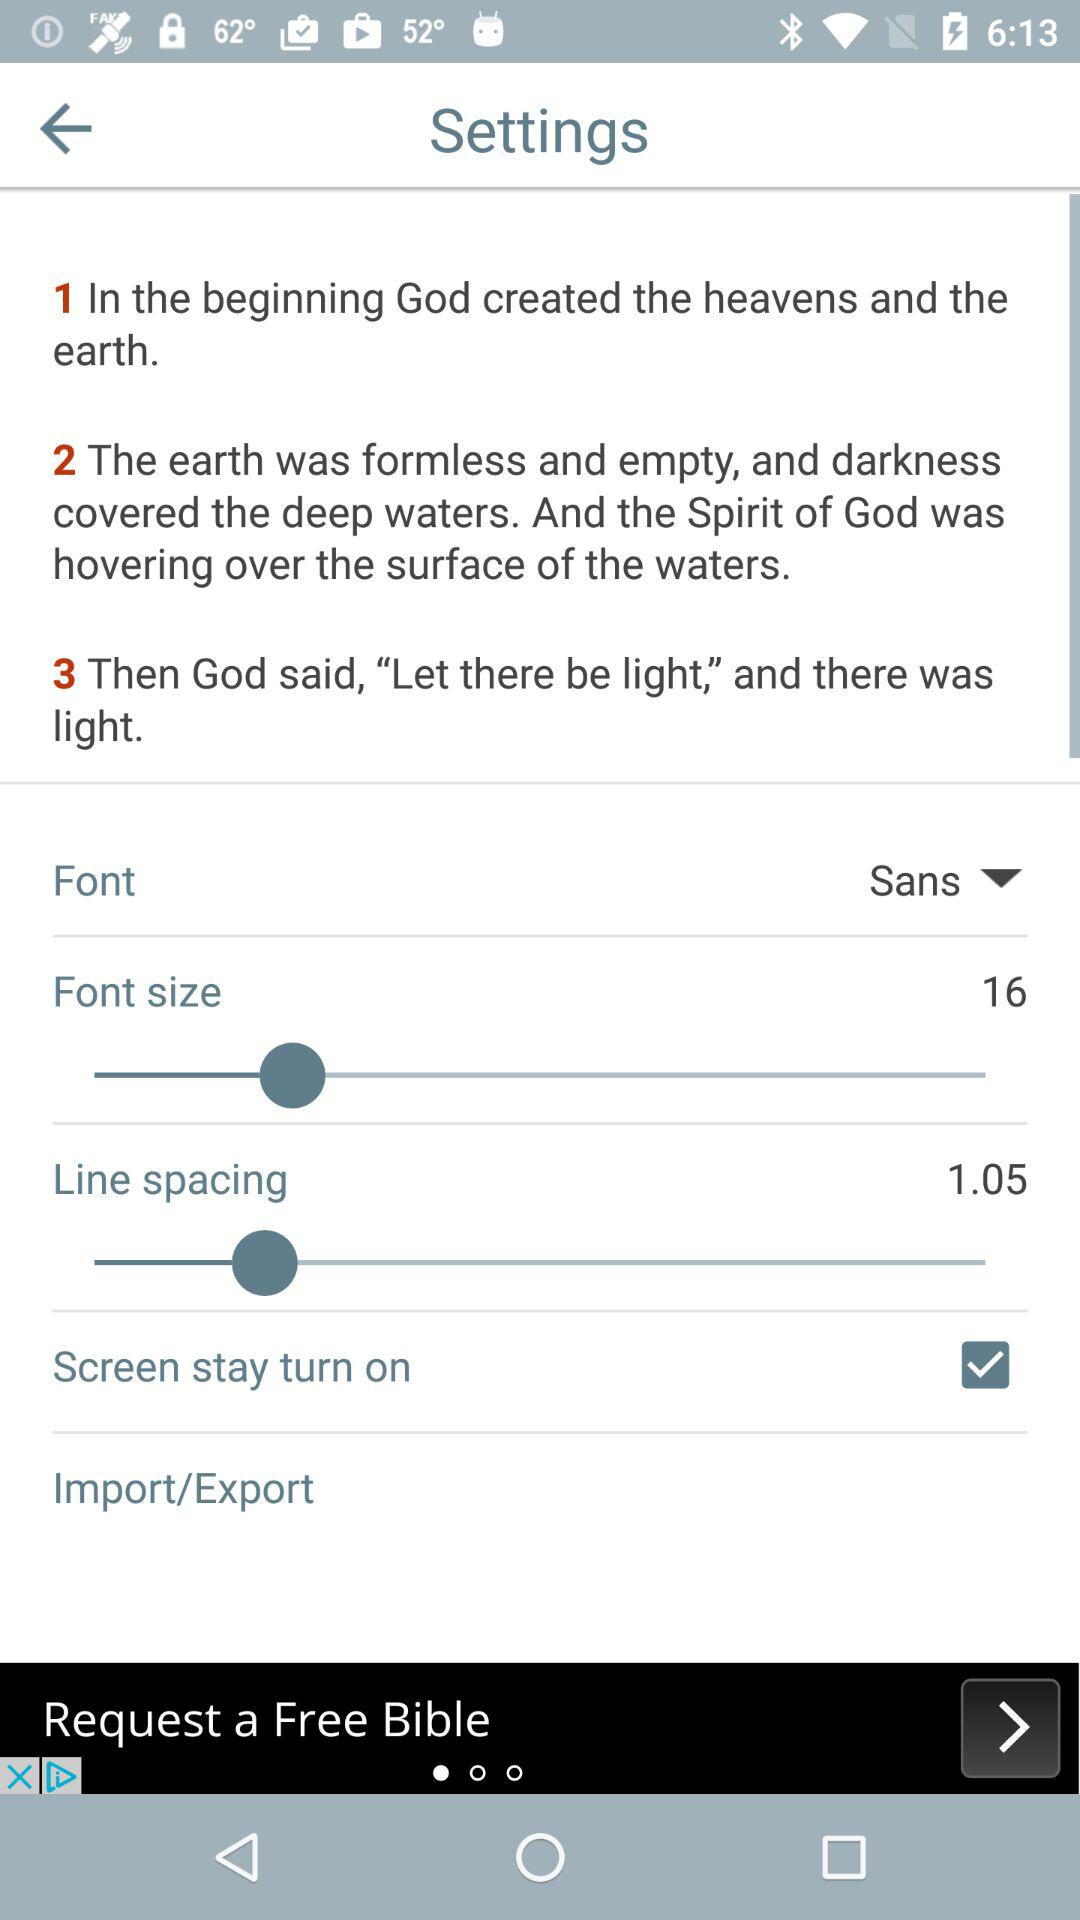What is the status of "Screen stay turn on"? The status is "on". 